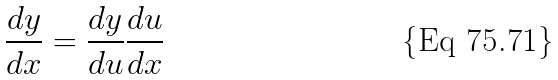<formula> <loc_0><loc_0><loc_500><loc_500>\frac { d y } { d x } = \frac { d y } { d u } \frac { d u } { d x }</formula> 